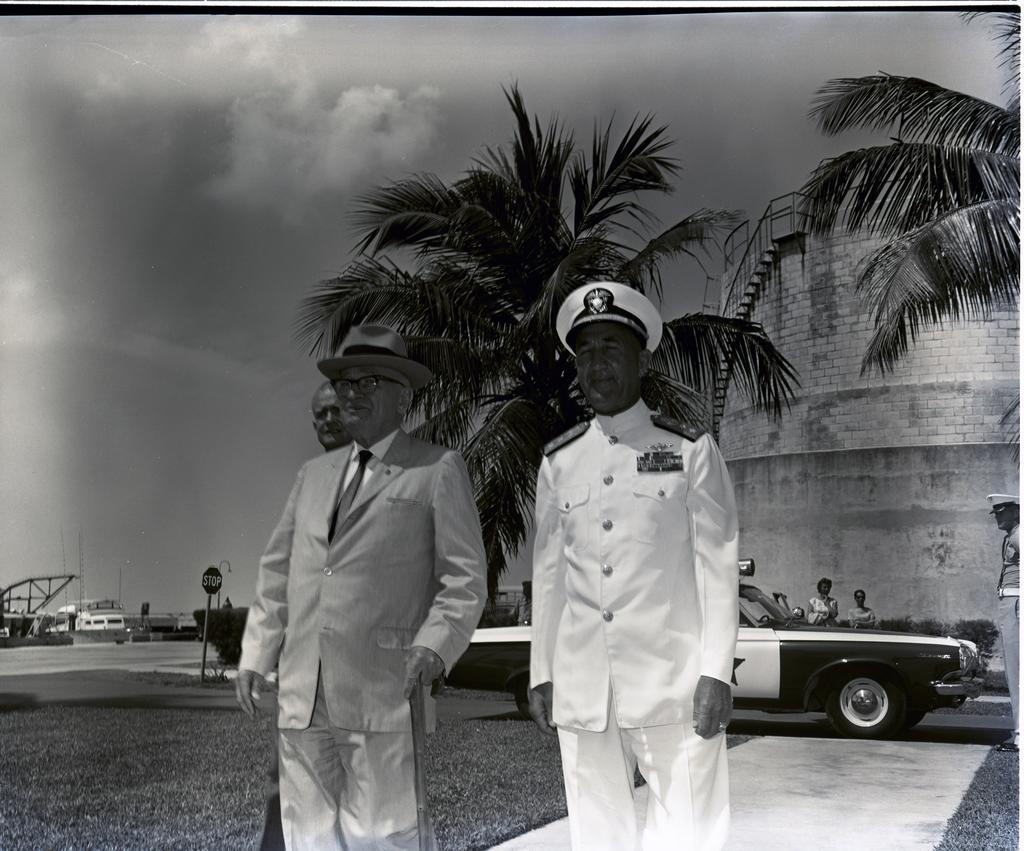Could you give a brief overview of what you see in this image? In this picture few people standing and I can see trees, plants and a car and I can see a sign board to the pole and a boat on the left side and looks like a building in the back and I can see a cloudy sky. 